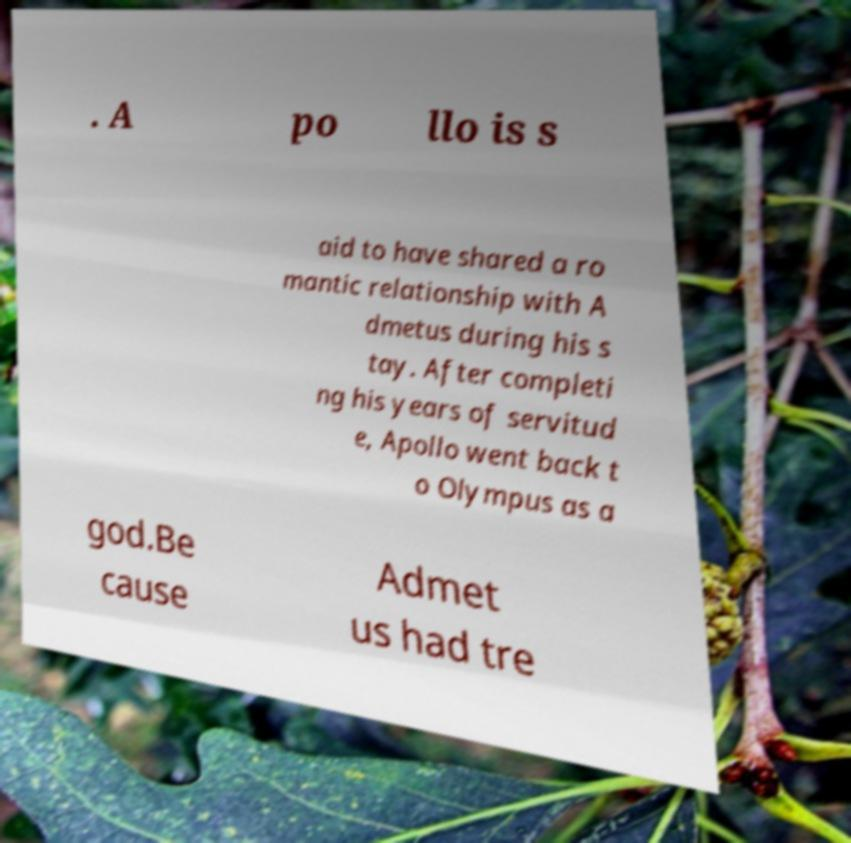There's text embedded in this image that I need extracted. Can you transcribe it verbatim? . A po llo is s aid to have shared a ro mantic relationship with A dmetus during his s tay. After completi ng his years of servitud e, Apollo went back t o Olympus as a god.Be cause Admet us had tre 